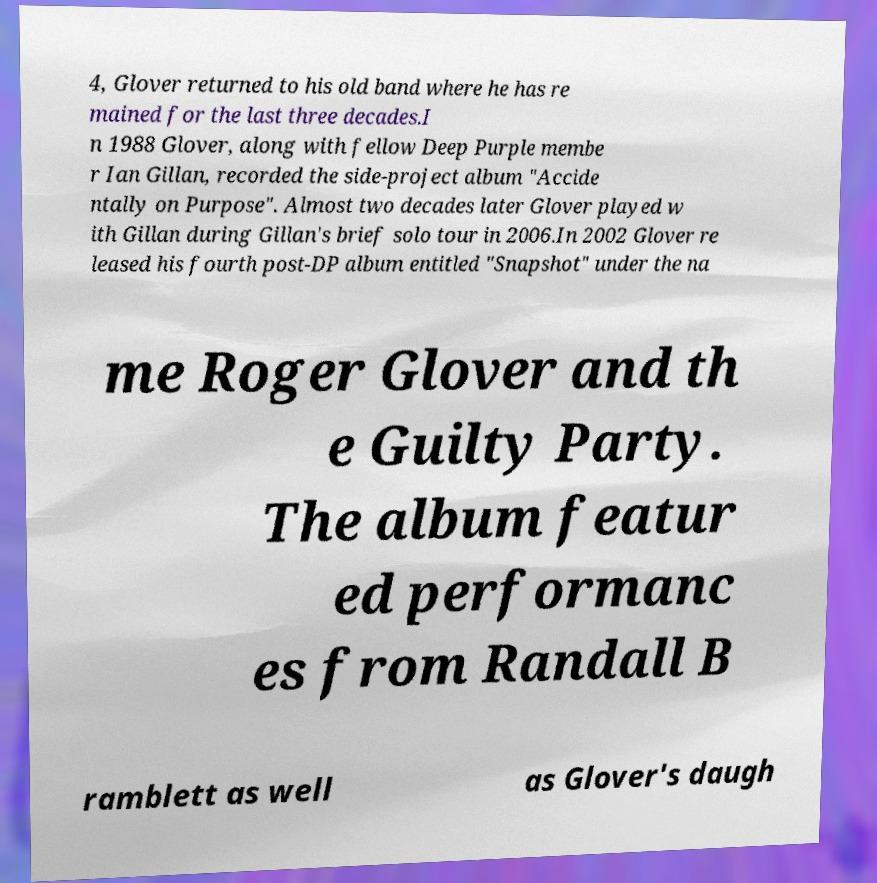For documentation purposes, I need the text within this image transcribed. Could you provide that? 4, Glover returned to his old band where he has re mained for the last three decades.I n 1988 Glover, along with fellow Deep Purple membe r Ian Gillan, recorded the side-project album "Accide ntally on Purpose". Almost two decades later Glover played w ith Gillan during Gillan's brief solo tour in 2006.In 2002 Glover re leased his fourth post-DP album entitled "Snapshot" under the na me Roger Glover and th e Guilty Party. The album featur ed performanc es from Randall B ramblett as well as Glover's daugh 